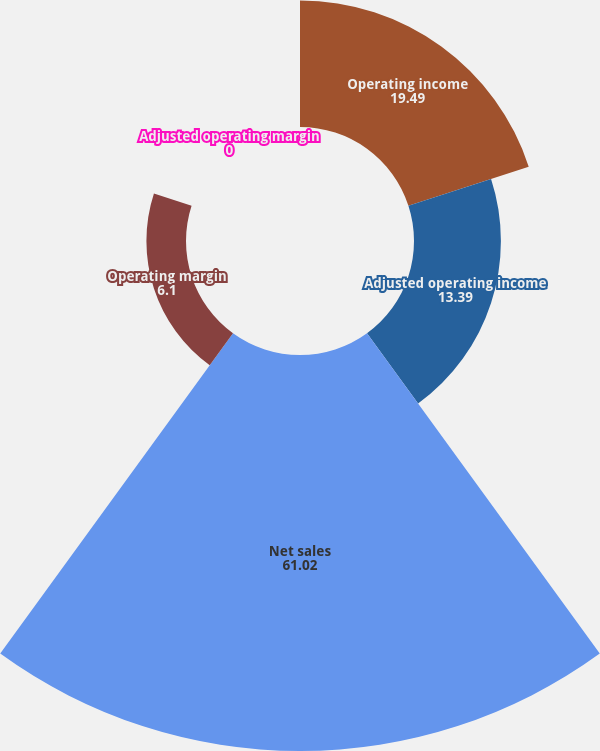Convert chart. <chart><loc_0><loc_0><loc_500><loc_500><pie_chart><fcel>Operating income<fcel>Adjusted operating income<fcel>Net sales<fcel>Operating margin<fcel>Adjusted operating margin<nl><fcel>19.49%<fcel>13.39%<fcel>61.02%<fcel>6.1%<fcel>0.0%<nl></chart> 